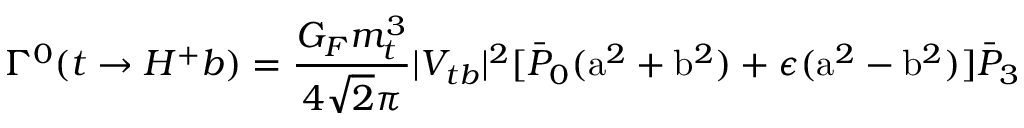Convert formula to latex. <formula><loc_0><loc_0><loc_500><loc_500>\Gamma ^ { 0 } ( t \rightarrow H ^ { + } b ) = \frac { G _ { F } m _ { t } ^ { 3 } } { 4 \sqrt { 2 } \pi } | V _ { t b } | ^ { 2 } [ \bar { P } _ { 0 } ( a ^ { 2 } + b ^ { 2 } ) + \epsilon ( a ^ { 2 } - b ^ { 2 } ) ] \bar { P } _ { 3 }</formula> 